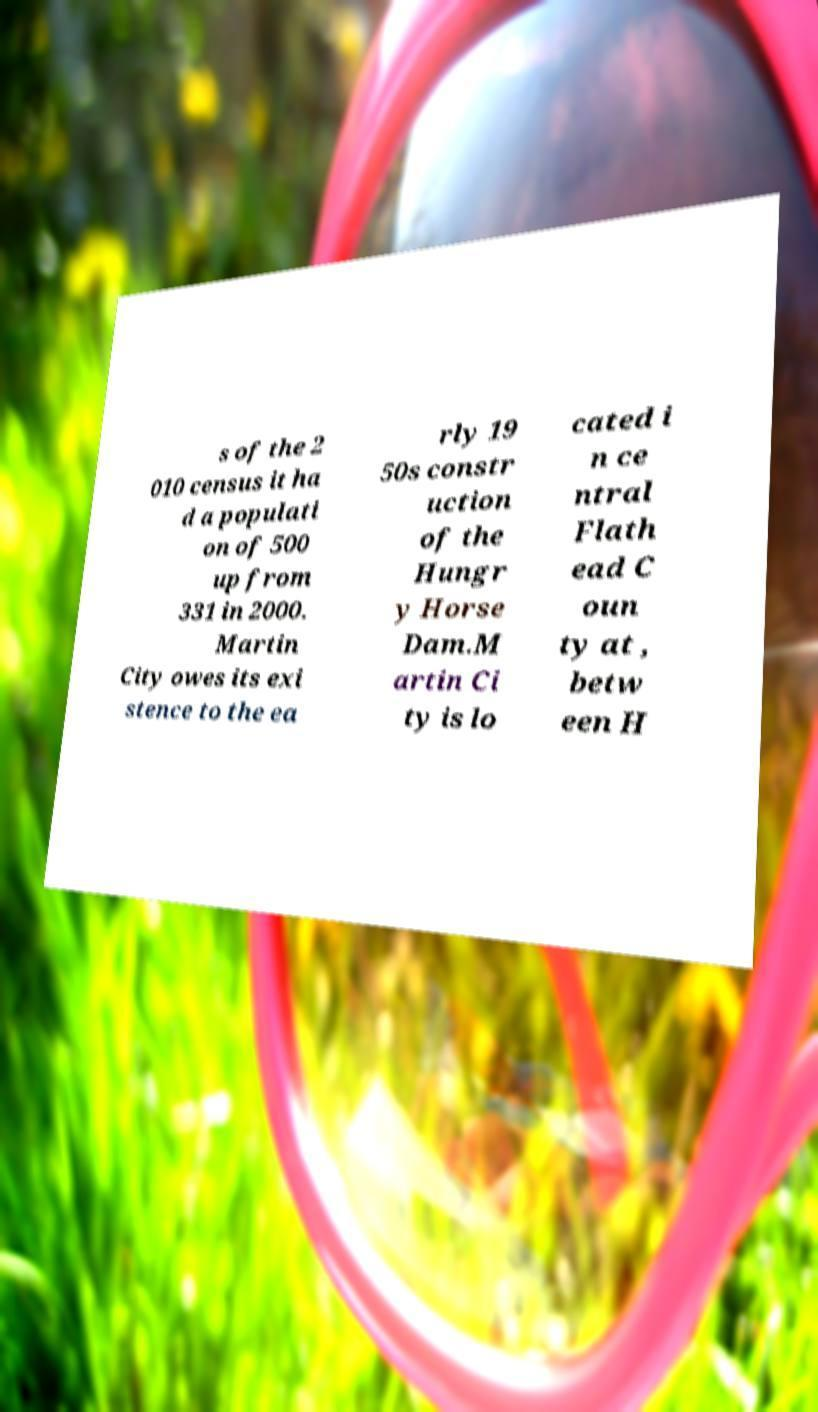For documentation purposes, I need the text within this image transcribed. Could you provide that? s of the 2 010 census it ha d a populati on of 500 up from 331 in 2000. Martin City owes its exi stence to the ea rly 19 50s constr uction of the Hungr y Horse Dam.M artin Ci ty is lo cated i n ce ntral Flath ead C oun ty at , betw een H 